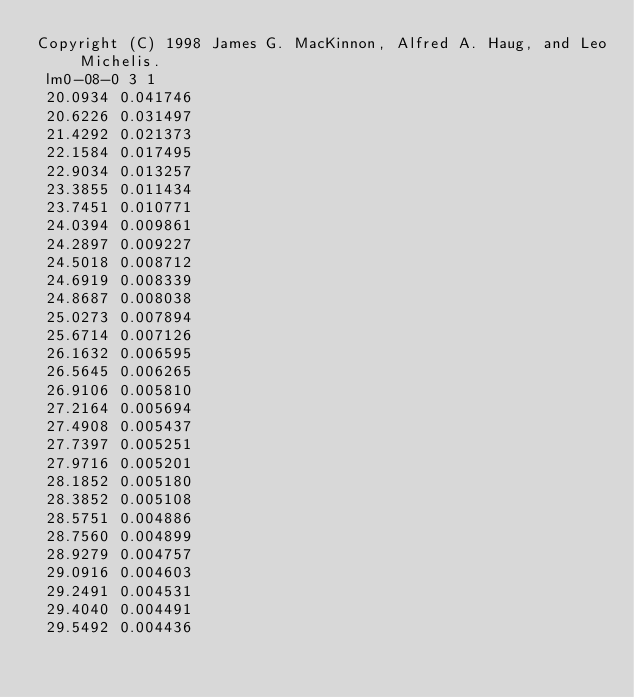<code> <loc_0><loc_0><loc_500><loc_500><_SQL_>Copyright (C) 1998 James G. MacKinnon, Alfred A. Haug, and Leo Michelis.
 lm0-08-0 3 1
 20.0934 0.041746
 20.6226 0.031497
 21.4292 0.021373
 22.1584 0.017495
 22.9034 0.013257
 23.3855 0.011434
 23.7451 0.010771
 24.0394 0.009861
 24.2897 0.009227
 24.5018 0.008712
 24.6919 0.008339
 24.8687 0.008038
 25.0273 0.007894
 25.6714 0.007126
 26.1632 0.006595
 26.5645 0.006265
 26.9106 0.005810
 27.2164 0.005694
 27.4908 0.005437
 27.7397 0.005251
 27.9716 0.005201
 28.1852 0.005180
 28.3852 0.005108
 28.5751 0.004886
 28.7560 0.004899
 28.9279 0.004757
 29.0916 0.004603
 29.2491 0.004531
 29.4040 0.004491
 29.5492 0.004436</code> 